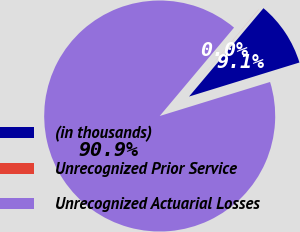Convert chart to OTSL. <chart><loc_0><loc_0><loc_500><loc_500><pie_chart><fcel>(in thousands)<fcel>Unrecognized Prior Service<fcel>Unrecognized Actuarial Losses<nl><fcel>9.1%<fcel>0.01%<fcel>90.89%<nl></chart> 